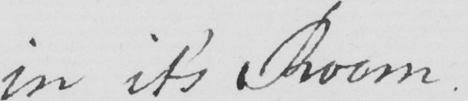Please provide the text content of this handwritten line. in it ' s Room . 